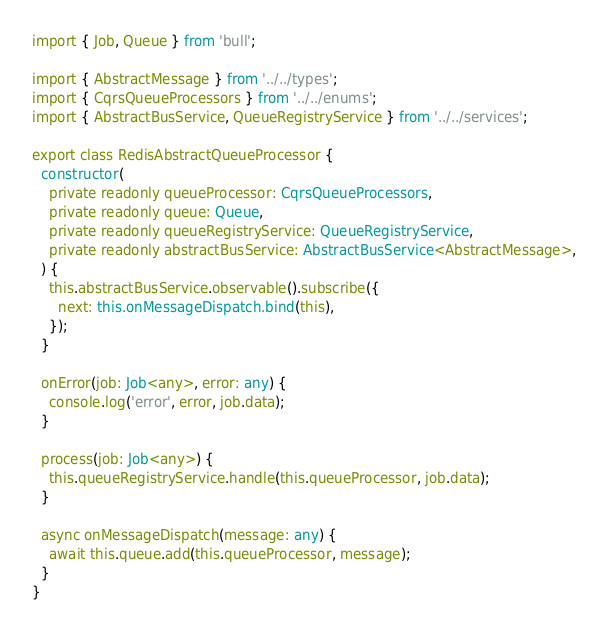<code> <loc_0><loc_0><loc_500><loc_500><_TypeScript_>import { Job, Queue } from 'bull';

import { AbstractMessage } from '../../types';
import { CqrsQueueProcessors } from '../../enums';
import { AbstractBusService, QueueRegistryService } from '../../services';

export class RedisAbstractQueueProcessor {
  constructor(
    private readonly queueProcessor: CqrsQueueProcessors,
    private readonly queue: Queue,
    private readonly queueRegistryService: QueueRegistryService,
    private readonly abstractBusService: AbstractBusService<AbstractMessage>,
  ) {
    this.abstractBusService.observable().subscribe({
      next: this.onMessageDispatch.bind(this),
    });
  }

  onError(job: Job<any>, error: any) {
    console.log('error', error, job.data);
  }

  process(job: Job<any>) {
    this.queueRegistryService.handle(this.queueProcessor, job.data);
  }

  async onMessageDispatch(message: any) {
    await this.queue.add(this.queueProcessor, message);
  }
}
</code> 